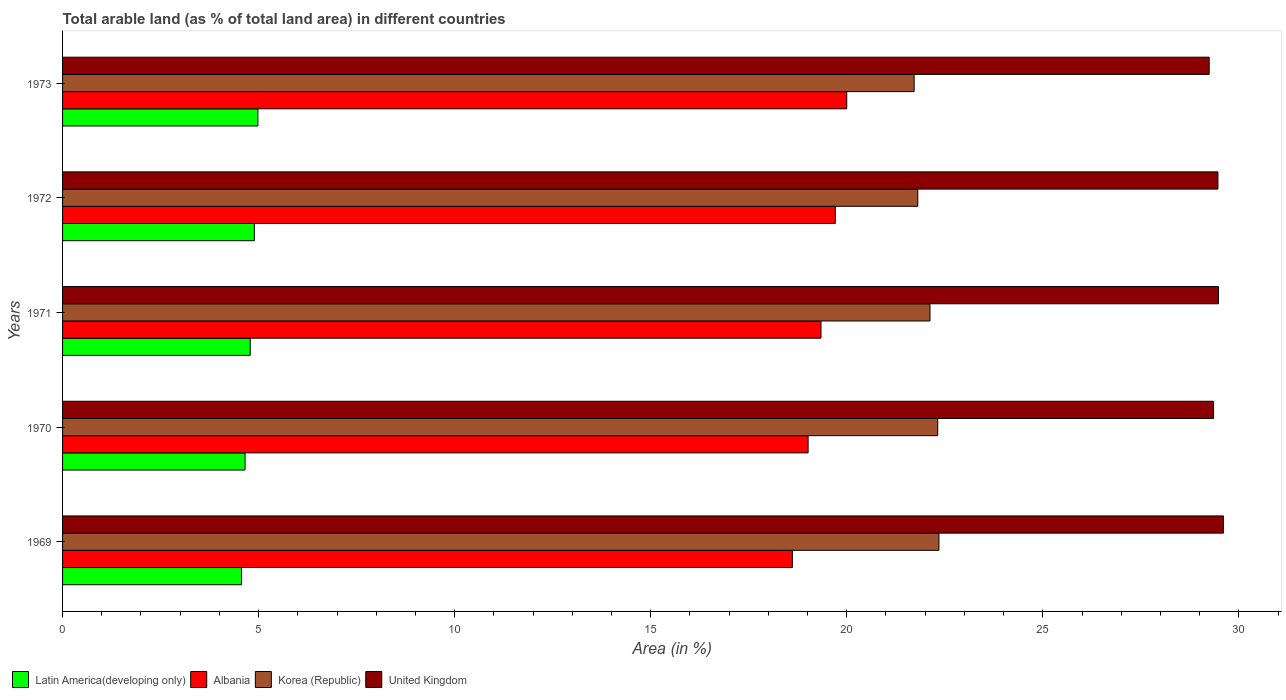How many different coloured bars are there?
Make the answer very short. 4. Are the number of bars per tick equal to the number of legend labels?
Provide a succinct answer. Yes. How many bars are there on the 5th tick from the top?
Your answer should be compact. 4. How many bars are there on the 2nd tick from the bottom?
Keep it short and to the point. 4. What is the percentage of arable land in Latin America(developing only) in 1972?
Ensure brevity in your answer.  4.89. Across all years, what is the maximum percentage of arable land in Latin America(developing only)?
Make the answer very short. 4.98. Across all years, what is the minimum percentage of arable land in Albania?
Your answer should be compact. 18.61. In which year was the percentage of arable land in Korea (Republic) maximum?
Offer a very short reply. 1969. In which year was the percentage of arable land in Korea (Republic) minimum?
Your response must be concise. 1973. What is the total percentage of arable land in Latin America(developing only) in the graph?
Your response must be concise. 23.88. What is the difference between the percentage of arable land in United Kingdom in 1971 and that in 1973?
Ensure brevity in your answer.  0.24. What is the difference between the percentage of arable land in Korea (Republic) in 1970 and the percentage of arable land in Albania in 1973?
Your answer should be compact. 2.32. What is the average percentage of arable land in Albania per year?
Your answer should be very brief. 19.34. In the year 1971, what is the difference between the percentage of arable land in United Kingdom and percentage of arable land in Korea (Republic)?
Provide a short and direct response. 7.36. What is the ratio of the percentage of arable land in Albania in 1969 to that in 1971?
Ensure brevity in your answer.  0.96. Is the percentage of arable land in Latin America(developing only) in 1969 less than that in 1970?
Offer a terse response. Yes. What is the difference between the highest and the second highest percentage of arable land in United Kingdom?
Make the answer very short. 0.13. What is the difference between the highest and the lowest percentage of arable land in Korea (Republic)?
Your answer should be compact. 0.63. In how many years, is the percentage of arable land in United Kingdom greater than the average percentage of arable land in United Kingdom taken over all years?
Offer a very short reply. 3. Is the sum of the percentage of arable land in Korea (Republic) in 1972 and 1973 greater than the maximum percentage of arable land in Albania across all years?
Offer a terse response. Yes. Is it the case that in every year, the sum of the percentage of arable land in United Kingdom and percentage of arable land in Latin America(developing only) is greater than the sum of percentage of arable land in Albania and percentage of arable land in Korea (Republic)?
Your answer should be very brief. No. What does the 2nd bar from the top in 1970 represents?
Offer a very short reply. Korea (Republic). What does the 1st bar from the bottom in 1973 represents?
Your answer should be very brief. Latin America(developing only). Are all the bars in the graph horizontal?
Make the answer very short. Yes. How many years are there in the graph?
Your response must be concise. 5. What is the difference between two consecutive major ticks on the X-axis?
Your answer should be compact. 5. Does the graph contain any zero values?
Make the answer very short. No. Does the graph contain grids?
Ensure brevity in your answer.  No. How many legend labels are there?
Give a very brief answer. 4. What is the title of the graph?
Your answer should be compact. Total arable land (as % of total land area) in different countries. What is the label or title of the X-axis?
Provide a short and direct response. Area (in %). What is the label or title of the Y-axis?
Your response must be concise. Years. What is the Area (in %) of Latin America(developing only) in 1969?
Provide a short and direct response. 4.56. What is the Area (in %) of Albania in 1969?
Offer a terse response. 18.61. What is the Area (in %) of Korea (Republic) in 1969?
Make the answer very short. 22.35. What is the Area (in %) of United Kingdom in 1969?
Your answer should be compact. 29.61. What is the Area (in %) of Latin America(developing only) in 1970?
Offer a very short reply. 4.65. What is the Area (in %) of Albania in 1970?
Your answer should be compact. 19.01. What is the Area (in %) in Korea (Republic) in 1970?
Offer a terse response. 22.32. What is the Area (in %) of United Kingdom in 1970?
Make the answer very short. 29.36. What is the Area (in %) in Latin America(developing only) in 1971?
Keep it short and to the point. 4.79. What is the Area (in %) in Albania in 1971?
Make the answer very short. 19.34. What is the Area (in %) of Korea (Republic) in 1971?
Keep it short and to the point. 22.12. What is the Area (in %) of United Kingdom in 1971?
Provide a short and direct response. 29.48. What is the Area (in %) of Latin America(developing only) in 1972?
Offer a terse response. 4.89. What is the Area (in %) in Albania in 1972?
Ensure brevity in your answer.  19.71. What is the Area (in %) in Korea (Republic) in 1972?
Make the answer very short. 21.81. What is the Area (in %) of United Kingdom in 1972?
Your response must be concise. 29.47. What is the Area (in %) of Latin America(developing only) in 1973?
Keep it short and to the point. 4.98. What is the Area (in %) in Korea (Republic) in 1973?
Provide a succinct answer. 21.72. What is the Area (in %) in United Kingdom in 1973?
Keep it short and to the point. 29.24. Across all years, what is the maximum Area (in %) in Latin America(developing only)?
Offer a terse response. 4.98. Across all years, what is the maximum Area (in %) in Korea (Republic)?
Make the answer very short. 22.35. Across all years, what is the maximum Area (in %) of United Kingdom?
Your response must be concise. 29.61. Across all years, what is the minimum Area (in %) in Latin America(developing only)?
Offer a terse response. 4.56. Across all years, what is the minimum Area (in %) in Albania?
Keep it short and to the point. 18.61. Across all years, what is the minimum Area (in %) of Korea (Republic)?
Give a very brief answer. 21.72. Across all years, what is the minimum Area (in %) of United Kingdom?
Your answer should be very brief. 29.24. What is the total Area (in %) in Latin America(developing only) in the graph?
Your response must be concise. 23.88. What is the total Area (in %) in Albania in the graph?
Give a very brief answer. 96.68. What is the total Area (in %) of Korea (Republic) in the graph?
Offer a terse response. 110.33. What is the total Area (in %) of United Kingdom in the graph?
Your answer should be compact. 147.15. What is the difference between the Area (in %) in Latin America(developing only) in 1969 and that in 1970?
Make the answer very short. -0.09. What is the difference between the Area (in %) in Albania in 1969 and that in 1970?
Your response must be concise. -0.4. What is the difference between the Area (in %) in Korea (Republic) in 1969 and that in 1970?
Offer a very short reply. 0.03. What is the difference between the Area (in %) of United Kingdom in 1969 and that in 1970?
Offer a very short reply. 0.25. What is the difference between the Area (in %) in Latin America(developing only) in 1969 and that in 1971?
Your answer should be very brief. -0.22. What is the difference between the Area (in %) of Albania in 1969 and that in 1971?
Ensure brevity in your answer.  -0.73. What is the difference between the Area (in %) in Korea (Republic) in 1969 and that in 1971?
Offer a terse response. 0.23. What is the difference between the Area (in %) of United Kingdom in 1969 and that in 1971?
Your answer should be compact. 0.13. What is the difference between the Area (in %) of Latin America(developing only) in 1969 and that in 1972?
Your answer should be compact. -0.33. What is the difference between the Area (in %) of Albania in 1969 and that in 1972?
Your response must be concise. -1.09. What is the difference between the Area (in %) of Korea (Republic) in 1969 and that in 1972?
Your answer should be very brief. 0.54. What is the difference between the Area (in %) of United Kingdom in 1969 and that in 1972?
Your response must be concise. 0.14. What is the difference between the Area (in %) in Latin America(developing only) in 1969 and that in 1973?
Offer a very short reply. -0.42. What is the difference between the Area (in %) of Albania in 1969 and that in 1973?
Your response must be concise. -1.39. What is the difference between the Area (in %) in Korea (Republic) in 1969 and that in 1973?
Offer a terse response. 0.63. What is the difference between the Area (in %) of United Kingdom in 1969 and that in 1973?
Provide a succinct answer. 0.36. What is the difference between the Area (in %) of Latin America(developing only) in 1970 and that in 1971?
Give a very brief answer. -0.13. What is the difference between the Area (in %) in Albania in 1970 and that in 1971?
Ensure brevity in your answer.  -0.33. What is the difference between the Area (in %) of Korea (Republic) in 1970 and that in 1971?
Provide a succinct answer. 0.2. What is the difference between the Area (in %) in United Kingdom in 1970 and that in 1971?
Your answer should be compact. -0.12. What is the difference between the Area (in %) in Latin America(developing only) in 1970 and that in 1972?
Provide a succinct answer. -0.24. What is the difference between the Area (in %) in Albania in 1970 and that in 1972?
Your answer should be very brief. -0.69. What is the difference between the Area (in %) of Korea (Republic) in 1970 and that in 1972?
Your answer should be compact. 0.51. What is the difference between the Area (in %) in United Kingdom in 1970 and that in 1972?
Offer a terse response. -0.11. What is the difference between the Area (in %) in Latin America(developing only) in 1970 and that in 1973?
Your response must be concise. -0.33. What is the difference between the Area (in %) of Albania in 1970 and that in 1973?
Ensure brevity in your answer.  -0.99. What is the difference between the Area (in %) of Korea (Republic) in 1970 and that in 1973?
Give a very brief answer. 0.6. What is the difference between the Area (in %) in United Kingdom in 1970 and that in 1973?
Your response must be concise. 0.11. What is the difference between the Area (in %) in Latin America(developing only) in 1971 and that in 1972?
Make the answer very short. -0.11. What is the difference between the Area (in %) in Albania in 1971 and that in 1972?
Your response must be concise. -0.36. What is the difference between the Area (in %) of Korea (Republic) in 1971 and that in 1972?
Your answer should be compact. 0.31. What is the difference between the Area (in %) in United Kingdom in 1971 and that in 1972?
Your answer should be compact. 0.01. What is the difference between the Area (in %) in Latin America(developing only) in 1971 and that in 1973?
Make the answer very short. -0.19. What is the difference between the Area (in %) in Albania in 1971 and that in 1973?
Your answer should be very brief. -0.66. What is the difference between the Area (in %) of Korea (Republic) in 1971 and that in 1973?
Provide a short and direct response. 0.4. What is the difference between the Area (in %) in United Kingdom in 1971 and that in 1973?
Ensure brevity in your answer.  0.24. What is the difference between the Area (in %) in Latin America(developing only) in 1972 and that in 1973?
Ensure brevity in your answer.  -0.09. What is the difference between the Area (in %) of Albania in 1972 and that in 1973?
Provide a short and direct response. -0.29. What is the difference between the Area (in %) of Korea (Republic) in 1972 and that in 1973?
Keep it short and to the point. 0.09. What is the difference between the Area (in %) in United Kingdom in 1972 and that in 1973?
Offer a terse response. 0.22. What is the difference between the Area (in %) in Latin America(developing only) in 1969 and the Area (in %) in Albania in 1970?
Make the answer very short. -14.45. What is the difference between the Area (in %) of Latin America(developing only) in 1969 and the Area (in %) of Korea (Republic) in 1970?
Give a very brief answer. -17.76. What is the difference between the Area (in %) in Latin America(developing only) in 1969 and the Area (in %) in United Kingdom in 1970?
Your answer should be very brief. -24.79. What is the difference between the Area (in %) of Albania in 1969 and the Area (in %) of Korea (Republic) in 1970?
Keep it short and to the point. -3.71. What is the difference between the Area (in %) in Albania in 1969 and the Area (in %) in United Kingdom in 1970?
Offer a very short reply. -10.74. What is the difference between the Area (in %) in Korea (Republic) in 1969 and the Area (in %) in United Kingdom in 1970?
Make the answer very short. -7. What is the difference between the Area (in %) of Latin America(developing only) in 1969 and the Area (in %) of Albania in 1971?
Keep it short and to the point. -14.78. What is the difference between the Area (in %) in Latin America(developing only) in 1969 and the Area (in %) in Korea (Republic) in 1971?
Make the answer very short. -17.56. What is the difference between the Area (in %) in Latin America(developing only) in 1969 and the Area (in %) in United Kingdom in 1971?
Give a very brief answer. -24.92. What is the difference between the Area (in %) of Albania in 1969 and the Area (in %) of Korea (Republic) in 1971?
Keep it short and to the point. -3.51. What is the difference between the Area (in %) in Albania in 1969 and the Area (in %) in United Kingdom in 1971?
Your answer should be very brief. -10.87. What is the difference between the Area (in %) of Korea (Republic) in 1969 and the Area (in %) of United Kingdom in 1971?
Make the answer very short. -7.13. What is the difference between the Area (in %) of Latin America(developing only) in 1969 and the Area (in %) of Albania in 1972?
Offer a terse response. -15.15. What is the difference between the Area (in %) in Latin America(developing only) in 1969 and the Area (in %) in Korea (Republic) in 1972?
Your answer should be compact. -17.25. What is the difference between the Area (in %) of Latin America(developing only) in 1969 and the Area (in %) of United Kingdom in 1972?
Make the answer very short. -24.9. What is the difference between the Area (in %) of Albania in 1969 and the Area (in %) of Korea (Republic) in 1972?
Keep it short and to the point. -3.2. What is the difference between the Area (in %) of Albania in 1969 and the Area (in %) of United Kingdom in 1972?
Provide a short and direct response. -10.85. What is the difference between the Area (in %) of Korea (Republic) in 1969 and the Area (in %) of United Kingdom in 1972?
Offer a very short reply. -7.12. What is the difference between the Area (in %) in Latin America(developing only) in 1969 and the Area (in %) in Albania in 1973?
Ensure brevity in your answer.  -15.44. What is the difference between the Area (in %) in Latin America(developing only) in 1969 and the Area (in %) in Korea (Republic) in 1973?
Offer a terse response. -17.16. What is the difference between the Area (in %) in Latin America(developing only) in 1969 and the Area (in %) in United Kingdom in 1973?
Offer a terse response. -24.68. What is the difference between the Area (in %) of Albania in 1969 and the Area (in %) of Korea (Republic) in 1973?
Give a very brief answer. -3.11. What is the difference between the Area (in %) of Albania in 1969 and the Area (in %) of United Kingdom in 1973?
Provide a succinct answer. -10.63. What is the difference between the Area (in %) of Korea (Republic) in 1969 and the Area (in %) of United Kingdom in 1973?
Offer a very short reply. -6.89. What is the difference between the Area (in %) in Latin America(developing only) in 1970 and the Area (in %) in Albania in 1971?
Ensure brevity in your answer.  -14.69. What is the difference between the Area (in %) in Latin America(developing only) in 1970 and the Area (in %) in Korea (Republic) in 1971?
Provide a short and direct response. -17.47. What is the difference between the Area (in %) of Latin America(developing only) in 1970 and the Area (in %) of United Kingdom in 1971?
Make the answer very short. -24.82. What is the difference between the Area (in %) of Albania in 1970 and the Area (in %) of Korea (Republic) in 1971?
Your answer should be compact. -3.11. What is the difference between the Area (in %) of Albania in 1970 and the Area (in %) of United Kingdom in 1971?
Make the answer very short. -10.46. What is the difference between the Area (in %) of Korea (Republic) in 1970 and the Area (in %) of United Kingdom in 1971?
Ensure brevity in your answer.  -7.16. What is the difference between the Area (in %) of Latin America(developing only) in 1970 and the Area (in %) of Albania in 1972?
Ensure brevity in your answer.  -15.05. What is the difference between the Area (in %) in Latin America(developing only) in 1970 and the Area (in %) in Korea (Republic) in 1972?
Your answer should be very brief. -17.16. What is the difference between the Area (in %) in Latin America(developing only) in 1970 and the Area (in %) in United Kingdom in 1972?
Give a very brief answer. -24.81. What is the difference between the Area (in %) in Albania in 1970 and the Area (in %) in Korea (Republic) in 1972?
Offer a terse response. -2.8. What is the difference between the Area (in %) in Albania in 1970 and the Area (in %) in United Kingdom in 1972?
Provide a succinct answer. -10.45. What is the difference between the Area (in %) in Korea (Republic) in 1970 and the Area (in %) in United Kingdom in 1972?
Keep it short and to the point. -7.15. What is the difference between the Area (in %) in Latin America(developing only) in 1970 and the Area (in %) in Albania in 1973?
Keep it short and to the point. -15.35. What is the difference between the Area (in %) of Latin America(developing only) in 1970 and the Area (in %) of Korea (Republic) in 1973?
Offer a very short reply. -17.06. What is the difference between the Area (in %) in Latin America(developing only) in 1970 and the Area (in %) in United Kingdom in 1973?
Offer a very short reply. -24.59. What is the difference between the Area (in %) of Albania in 1970 and the Area (in %) of Korea (Republic) in 1973?
Your answer should be very brief. -2.7. What is the difference between the Area (in %) of Albania in 1970 and the Area (in %) of United Kingdom in 1973?
Your answer should be very brief. -10.23. What is the difference between the Area (in %) in Korea (Republic) in 1970 and the Area (in %) in United Kingdom in 1973?
Provide a succinct answer. -6.92. What is the difference between the Area (in %) in Latin America(developing only) in 1971 and the Area (in %) in Albania in 1972?
Provide a short and direct response. -14.92. What is the difference between the Area (in %) of Latin America(developing only) in 1971 and the Area (in %) of Korea (Republic) in 1972?
Offer a terse response. -17.03. What is the difference between the Area (in %) in Latin America(developing only) in 1971 and the Area (in %) in United Kingdom in 1972?
Your answer should be compact. -24.68. What is the difference between the Area (in %) in Albania in 1971 and the Area (in %) in Korea (Republic) in 1972?
Your answer should be very brief. -2.47. What is the difference between the Area (in %) of Albania in 1971 and the Area (in %) of United Kingdom in 1972?
Your answer should be very brief. -10.12. What is the difference between the Area (in %) of Korea (Republic) in 1971 and the Area (in %) of United Kingdom in 1972?
Give a very brief answer. -7.34. What is the difference between the Area (in %) of Latin America(developing only) in 1971 and the Area (in %) of Albania in 1973?
Your answer should be compact. -15.21. What is the difference between the Area (in %) in Latin America(developing only) in 1971 and the Area (in %) in Korea (Republic) in 1973?
Keep it short and to the point. -16.93. What is the difference between the Area (in %) in Latin America(developing only) in 1971 and the Area (in %) in United Kingdom in 1973?
Offer a very short reply. -24.46. What is the difference between the Area (in %) in Albania in 1971 and the Area (in %) in Korea (Republic) in 1973?
Give a very brief answer. -2.38. What is the difference between the Area (in %) of Albania in 1971 and the Area (in %) of United Kingdom in 1973?
Your answer should be very brief. -9.9. What is the difference between the Area (in %) in Korea (Republic) in 1971 and the Area (in %) in United Kingdom in 1973?
Keep it short and to the point. -7.12. What is the difference between the Area (in %) of Latin America(developing only) in 1972 and the Area (in %) of Albania in 1973?
Your response must be concise. -15.11. What is the difference between the Area (in %) of Latin America(developing only) in 1972 and the Area (in %) of Korea (Republic) in 1973?
Give a very brief answer. -16.83. What is the difference between the Area (in %) of Latin America(developing only) in 1972 and the Area (in %) of United Kingdom in 1973?
Offer a very short reply. -24.35. What is the difference between the Area (in %) in Albania in 1972 and the Area (in %) in Korea (Republic) in 1973?
Provide a short and direct response. -2.01. What is the difference between the Area (in %) of Albania in 1972 and the Area (in %) of United Kingdom in 1973?
Provide a short and direct response. -9.54. What is the difference between the Area (in %) of Korea (Republic) in 1972 and the Area (in %) of United Kingdom in 1973?
Your answer should be compact. -7.43. What is the average Area (in %) of Latin America(developing only) per year?
Your answer should be compact. 4.78. What is the average Area (in %) in Albania per year?
Give a very brief answer. 19.34. What is the average Area (in %) in Korea (Republic) per year?
Ensure brevity in your answer.  22.07. What is the average Area (in %) in United Kingdom per year?
Ensure brevity in your answer.  29.43. In the year 1969, what is the difference between the Area (in %) of Latin America(developing only) and Area (in %) of Albania?
Your answer should be very brief. -14.05. In the year 1969, what is the difference between the Area (in %) of Latin America(developing only) and Area (in %) of Korea (Republic)?
Offer a very short reply. -17.79. In the year 1969, what is the difference between the Area (in %) in Latin America(developing only) and Area (in %) in United Kingdom?
Offer a terse response. -25.04. In the year 1969, what is the difference between the Area (in %) in Albania and Area (in %) in Korea (Republic)?
Give a very brief answer. -3.74. In the year 1969, what is the difference between the Area (in %) of Albania and Area (in %) of United Kingdom?
Your response must be concise. -10.99. In the year 1969, what is the difference between the Area (in %) in Korea (Republic) and Area (in %) in United Kingdom?
Provide a succinct answer. -7.26. In the year 1970, what is the difference between the Area (in %) in Latin America(developing only) and Area (in %) in Albania?
Provide a short and direct response. -14.36. In the year 1970, what is the difference between the Area (in %) of Latin America(developing only) and Area (in %) of Korea (Republic)?
Ensure brevity in your answer.  -17.67. In the year 1970, what is the difference between the Area (in %) of Latin America(developing only) and Area (in %) of United Kingdom?
Your answer should be compact. -24.7. In the year 1970, what is the difference between the Area (in %) in Albania and Area (in %) in Korea (Republic)?
Your answer should be compact. -3.31. In the year 1970, what is the difference between the Area (in %) of Albania and Area (in %) of United Kingdom?
Your answer should be very brief. -10.34. In the year 1970, what is the difference between the Area (in %) of Korea (Republic) and Area (in %) of United Kingdom?
Offer a terse response. -7.04. In the year 1971, what is the difference between the Area (in %) in Latin America(developing only) and Area (in %) in Albania?
Give a very brief answer. -14.56. In the year 1971, what is the difference between the Area (in %) of Latin America(developing only) and Area (in %) of Korea (Republic)?
Ensure brevity in your answer.  -17.34. In the year 1971, what is the difference between the Area (in %) of Latin America(developing only) and Area (in %) of United Kingdom?
Offer a terse response. -24.69. In the year 1971, what is the difference between the Area (in %) of Albania and Area (in %) of Korea (Republic)?
Your answer should be compact. -2.78. In the year 1971, what is the difference between the Area (in %) of Albania and Area (in %) of United Kingdom?
Offer a terse response. -10.14. In the year 1971, what is the difference between the Area (in %) in Korea (Republic) and Area (in %) in United Kingdom?
Your response must be concise. -7.36. In the year 1972, what is the difference between the Area (in %) in Latin America(developing only) and Area (in %) in Albania?
Provide a succinct answer. -14.82. In the year 1972, what is the difference between the Area (in %) of Latin America(developing only) and Area (in %) of Korea (Republic)?
Your response must be concise. -16.92. In the year 1972, what is the difference between the Area (in %) in Latin America(developing only) and Area (in %) in United Kingdom?
Provide a succinct answer. -24.58. In the year 1972, what is the difference between the Area (in %) in Albania and Area (in %) in Korea (Republic)?
Provide a succinct answer. -2.1. In the year 1972, what is the difference between the Area (in %) in Albania and Area (in %) in United Kingdom?
Provide a short and direct response. -9.76. In the year 1972, what is the difference between the Area (in %) of Korea (Republic) and Area (in %) of United Kingdom?
Provide a succinct answer. -7.66. In the year 1973, what is the difference between the Area (in %) of Latin America(developing only) and Area (in %) of Albania?
Your response must be concise. -15.02. In the year 1973, what is the difference between the Area (in %) of Latin America(developing only) and Area (in %) of Korea (Republic)?
Give a very brief answer. -16.74. In the year 1973, what is the difference between the Area (in %) of Latin America(developing only) and Area (in %) of United Kingdom?
Keep it short and to the point. -24.26. In the year 1973, what is the difference between the Area (in %) of Albania and Area (in %) of Korea (Republic)?
Keep it short and to the point. -1.72. In the year 1973, what is the difference between the Area (in %) of Albania and Area (in %) of United Kingdom?
Keep it short and to the point. -9.24. In the year 1973, what is the difference between the Area (in %) in Korea (Republic) and Area (in %) in United Kingdom?
Ensure brevity in your answer.  -7.53. What is the ratio of the Area (in %) of Latin America(developing only) in 1969 to that in 1970?
Your answer should be very brief. 0.98. What is the ratio of the Area (in %) in Albania in 1969 to that in 1970?
Provide a succinct answer. 0.98. What is the ratio of the Area (in %) of Korea (Republic) in 1969 to that in 1970?
Keep it short and to the point. 1. What is the ratio of the Area (in %) of United Kingdom in 1969 to that in 1970?
Give a very brief answer. 1.01. What is the ratio of the Area (in %) of Latin America(developing only) in 1969 to that in 1971?
Provide a succinct answer. 0.95. What is the ratio of the Area (in %) of Albania in 1969 to that in 1971?
Offer a terse response. 0.96. What is the ratio of the Area (in %) of Korea (Republic) in 1969 to that in 1971?
Provide a succinct answer. 1.01. What is the ratio of the Area (in %) in United Kingdom in 1969 to that in 1971?
Your response must be concise. 1. What is the ratio of the Area (in %) of Latin America(developing only) in 1969 to that in 1972?
Ensure brevity in your answer.  0.93. What is the ratio of the Area (in %) in Albania in 1969 to that in 1972?
Make the answer very short. 0.94. What is the ratio of the Area (in %) in Korea (Republic) in 1969 to that in 1972?
Your answer should be very brief. 1.02. What is the ratio of the Area (in %) of United Kingdom in 1969 to that in 1972?
Offer a very short reply. 1. What is the ratio of the Area (in %) in Latin America(developing only) in 1969 to that in 1973?
Your answer should be very brief. 0.92. What is the ratio of the Area (in %) of Albania in 1969 to that in 1973?
Give a very brief answer. 0.93. What is the ratio of the Area (in %) of Korea (Republic) in 1969 to that in 1973?
Your answer should be compact. 1.03. What is the ratio of the Area (in %) in United Kingdom in 1969 to that in 1973?
Your answer should be compact. 1.01. What is the ratio of the Area (in %) of Latin America(developing only) in 1970 to that in 1971?
Offer a terse response. 0.97. What is the ratio of the Area (in %) of Korea (Republic) in 1970 to that in 1971?
Your response must be concise. 1.01. What is the ratio of the Area (in %) of Latin America(developing only) in 1970 to that in 1972?
Your answer should be very brief. 0.95. What is the ratio of the Area (in %) in Albania in 1970 to that in 1972?
Keep it short and to the point. 0.96. What is the ratio of the Area (in %) in Korea (Republic) in 1970 to that in 1972?
Your response must be concise. 1.02. What is the ratio of the Area (in %) of Latin America(developing only) in 1970 to that in 1973?
Make the answer very short. 0.93. What is the ratio of the Area (in %) in Albania in 1970 to that in 1973?
Make the answer very short. 0.95. What is the ratio of the Area (in %) in Korea (Republic) in 1970 to that in 1973?
Give a very brief answer. 1.03. What is the ratio of the Area (in %) in Latin America(developing only) in 1971 to that in 1972?
Provide a succinct answer. 0.98. What is the ratio of the Area (in %) in Albania in 1971 to that in 1972?
Provide a short and direct response. 0.98. What is the ratio of the Area (in %) of Korea (Republic) in 1971 to that in 1972?
Offer a terse response. 1.01. What is the ratio of the Area (in %) in Latin America(developing only) in 1971 to that in 1973?
Provide a succinct answer. 0.96. What is the ratio of the Area (in %) in Albania in 1971 to that in 1973?
Offer a very short reply. 0.97. What is the ratio of the Area (in %) in Korea (Republic) in 1971 to that in 1973?
Your response must be concise. 1.02. What is the ratio of the Area (in %) in United Kingdom in 1971 to that in 1973?
Your response must be concise. 1.01. What is the ratio of the Area (in %) in Albania in 1972 to that in 1973?
Your response must be concise. 0.99. What is the ratio of the Area (in %) in Korea (Republic) in 1972 to that in 1973?
Your answer should be very brief. 1. What is the ratio of the Area (in %) of United Kingdom in 1972 to that in 1973?
Provide a succinct answer. 1.01. What is the difference between the highest and the second highest Area (in %) of Latin America(developing only)?
Offer a terse response. 0.09. What is the difference between the highest and the second highest Area (in %) of Albania?
Give a very brief answer. 0.29. What is the difference between the highest and the second highest Area (in %) of Korea (Republic)?
Make the answer very short. 0.03. What is the difference between the highest and the second highest Area (in %) in United Kingdom?
Offer a very short reply. 0.13. What is the difference between the highest and the lowest Area (in %) in Latin America(developing only)?
Give a very brief answer. 0.42. What is the difference between the highest and the lowest Area (in %) in Albania?
Your answer should be compact. 1.39. What is the difference between the highest and the lowest Area (in %) in Korea (Republic)?
Give a very brief answer. 0.63. What is the difference between the highest and the lowest Area (in %) of United Kingdom?
Your answer should be very brief. 0.36. 